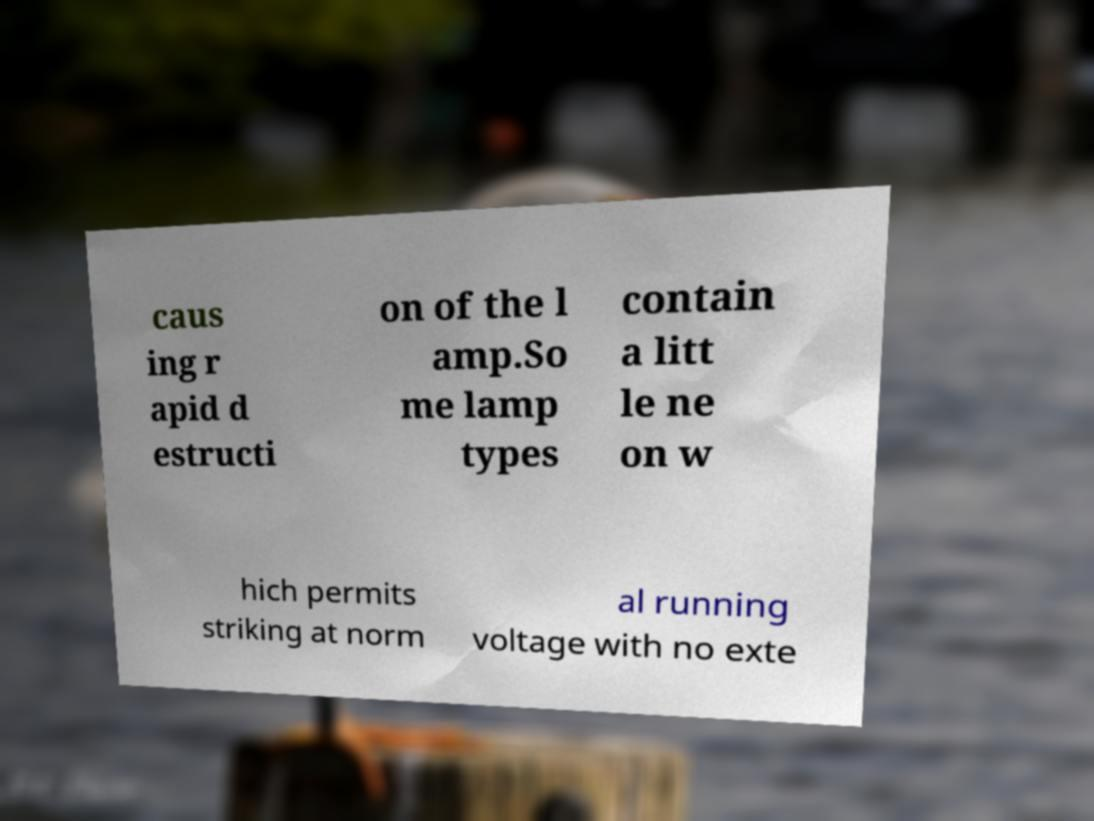Please read and relay the text visible in this image. What does it say? caus ing r apid d estructi on of the l amp.So me lamp types contain a litt le ne on w hich permits striking at norm al running voltage with no exte 